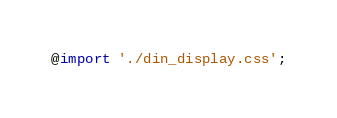<code> <loc_0><loc_0><loc_500><loc_500><_CSS_>@import './din_display.css';
</code> 